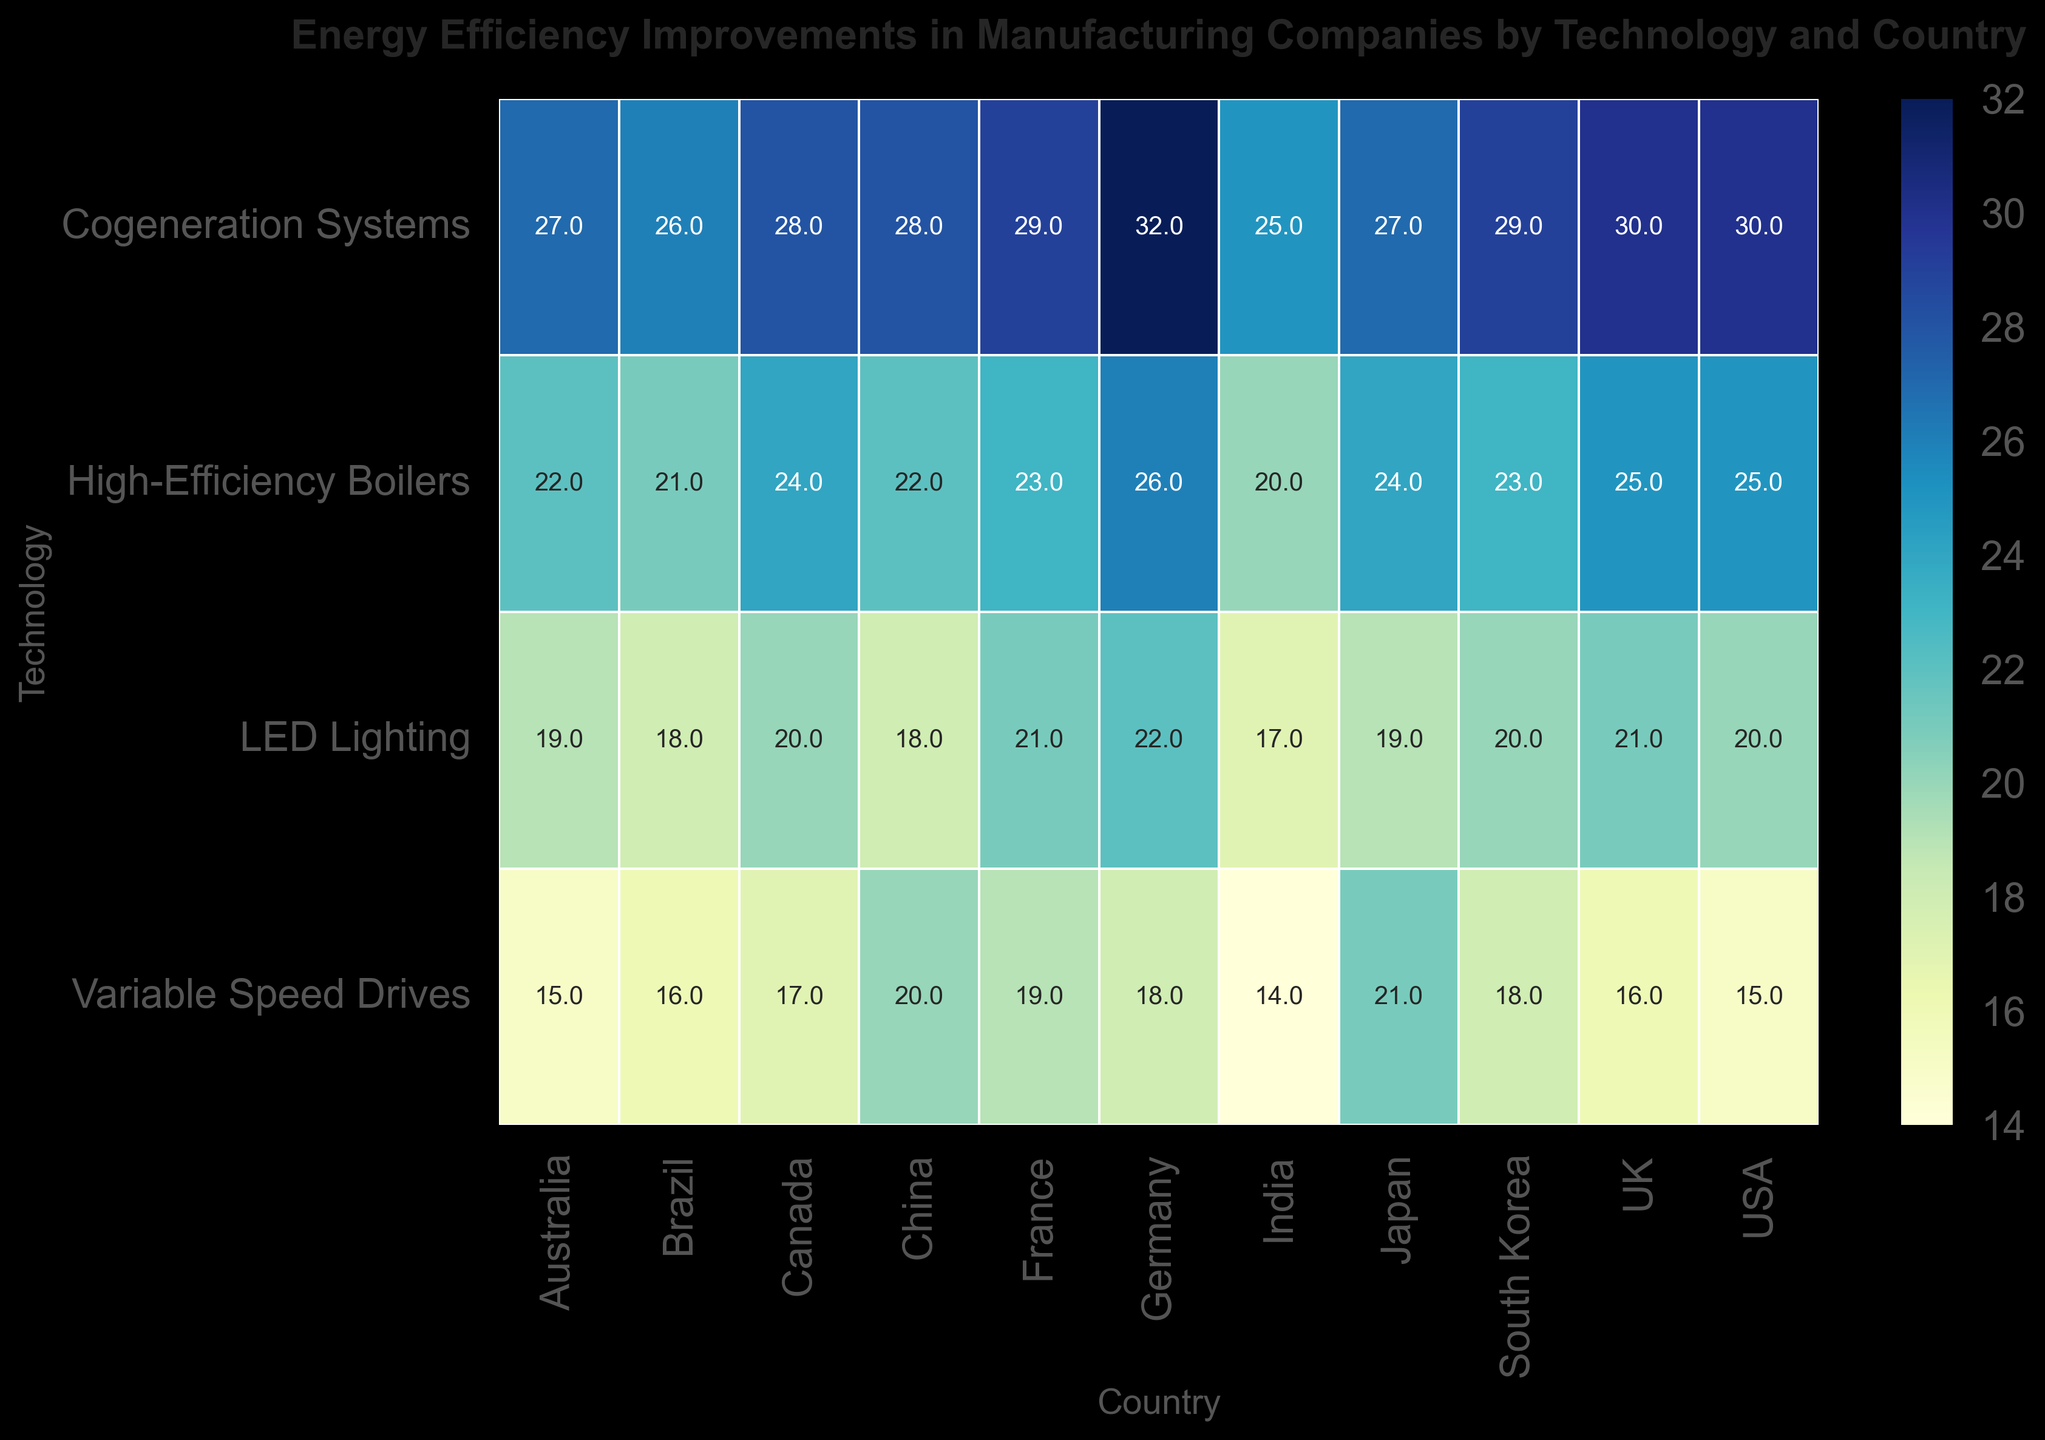What country shows the highest energy efficiency improvement for Cogeneration Systems? To find the country with the highest energy efficiency improvement for Cogeneration Systems, visually scan the heatmap row corresponding to Cogeneration Systems and identify the highest value. The value 32% corresponds to Germany.
Answer: Germany Which technology has the least energy efficiency improvement in India? To determine the technology with the least energy efficiency improvement in India, locate the column for India and identify the smallest value. The smallest value is 14%, which corresponds to Variable Speed Drives.
Answer: Variable Speed Drives How does the energy efficiency improvement of LED Lighting in the UK compare to that in Brazil? Compare the values for LED Lighting in the UK and Brazil by looking at their respective cells. The value for the UK is 21% and for Brazil, it is 18%.
Answer: 21% in the UK is higher than 18% in Brazil For LED Lighting, which country achieved the highest energy efficiency improvement? Scan the LED Lighting row to find the highest value. The value 22% corresponds to Germany.
Answer: Germany What’s the average energy efficiency improvement for High-Efficiency Boilers across all listed countries? Add the values for High-Efficiency Boilers across all countries (25+22+26+24+20+23+21+24+23) and divide by the number of countries (9). The sum is 208%, so the average is 208/9 ≈ 23.1%.
Answer: 23.1% Does Canada or Australia have a greater energy efficiency improvement in Variable Speed Drives? Locate and compare the Variable Speed Drives values for Canada and Australia. Canada’s value is 17%, while Australia’s value is 15%.
Answer: Canada Which country saw the smallest energy efficiency improvement with Cogeneration Systems? Look at the Cogeneration Systems row and identify the smallest value. The smallest value is 25%, which corresponds to India and Brazil.
Answer: India and Brazil What is the difference in energy efficiency improvement for High-Efficiency Boilers between Germany and Japan? Find the values for High-Efficiency Boilers in Germany and Japan. The values are 26% and 24% respectively. The difference is 26% - 24% = 2%.
Answer: 2% Which technology consistently shows the highest energy efficiency improvements across countries? For each technology row, count which one has the most frequent high values. Cogeneration Systems often have the highest values.
Answer: Cogeneration Systems What is the median energy efficiency improvement for Variable Speed Drives across all countries? Organize the values for Variable Speed Drives (15, 14, 18, 21, 19, 16, 17, 16, 18) in ascending order and find the middle value. Ordered: 14, 15, 16, 16, 17, 18, 18, 19, 21. The median value is 17%.
Answer: 17% 